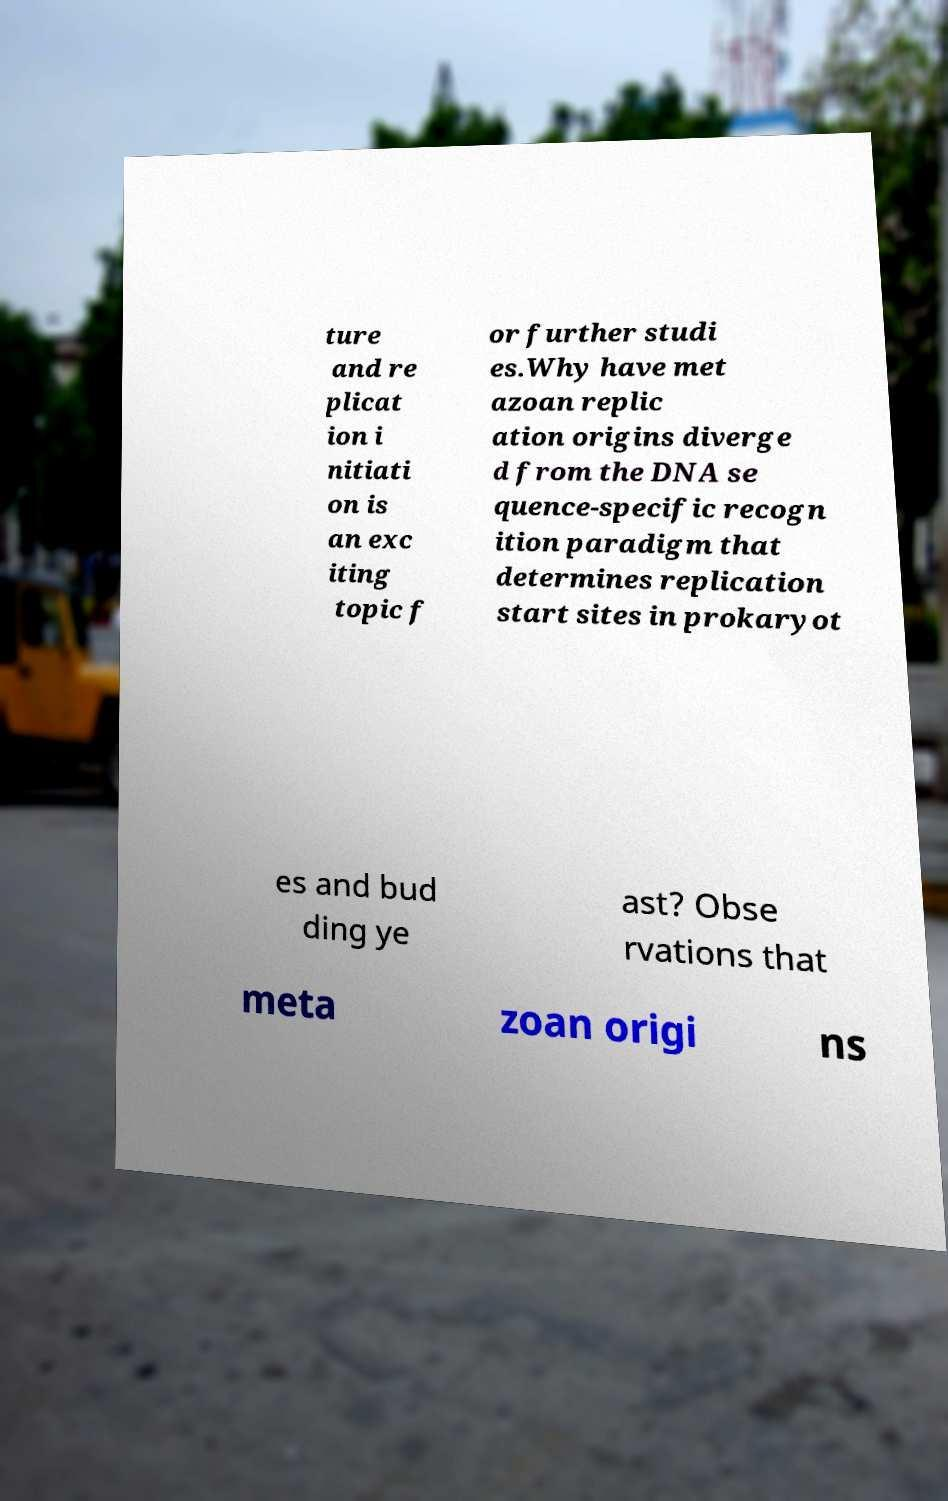For documentation purposes, I need the text within this image transcribed. Could you provide that? ture and re plicat ion i nitiati on is an exc iting topic f or further studi es.Why have met azoan replic ation origins diverge d from the DNA se quence-specific recogn ition paradigm that determines replication start sites in prokaryot es and bud ding ye ast? Obse rvations that meta zoan origi ns 